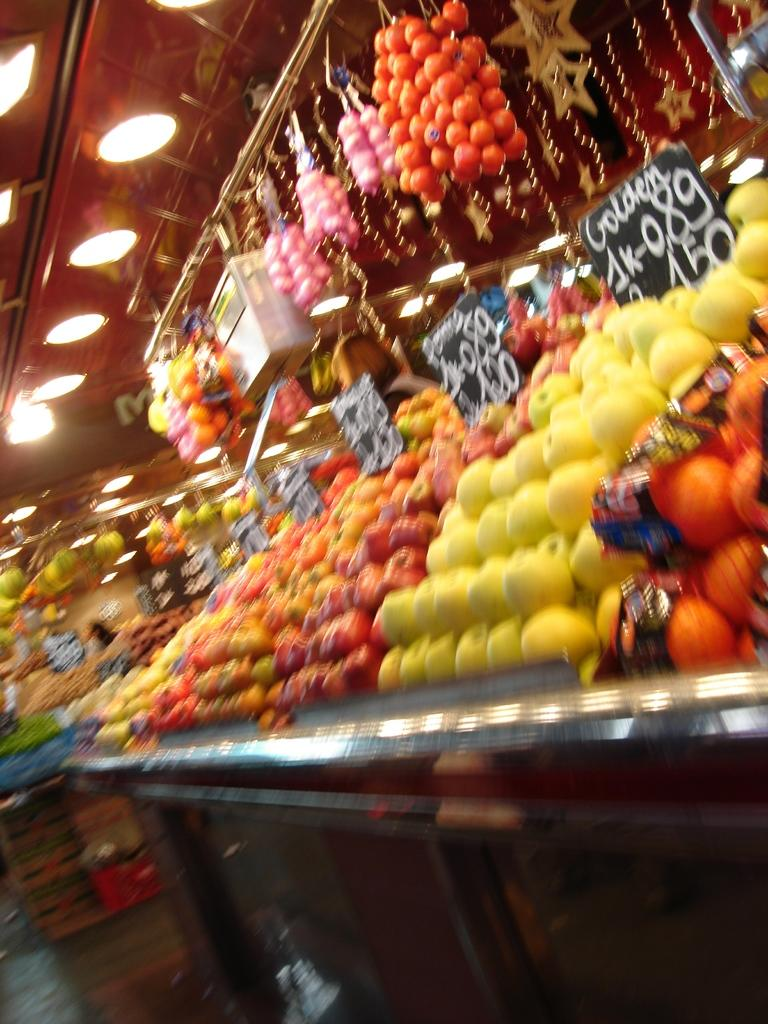What types of fruits can be seen in the image? There are many fruits in the image, with red, yellow, and orange colors. What can be seen in the background of the image? There are black-colored boards in the background. What is written on the boards? Something is written on the boards, but the specific text is not legible from the image. What else is visible in the image? There are lights visible in the image. How many trees can be seen in the image? There are no trees visible in the image; it primarily features fruits and boards. What type of ship is present in the image? There is no ship present in the image. 